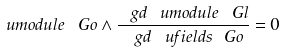Convert formula to latex. <formula><loc_0><loc_0><loc_500><loc_500>\ u m o d u l e { \ G o } \wedge \frac { \ g d \ u m o d u l e { \ G l } } { \ g d \ u f i e l d s { \ G o } } = 0</formula> 